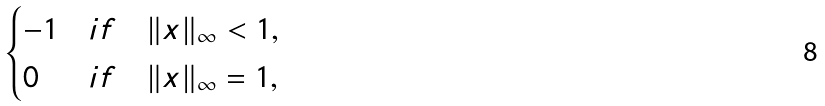Convert formula to latex. <formula><loc_0><loc_0><loc_500><loc_500>\begin{cases} - 1 & i f \quad \| x \| _ { \infty } < 1 , \\ 0 & i f \quad \| x \| _ { \infty } = 1 , \end{cases}</formula> 